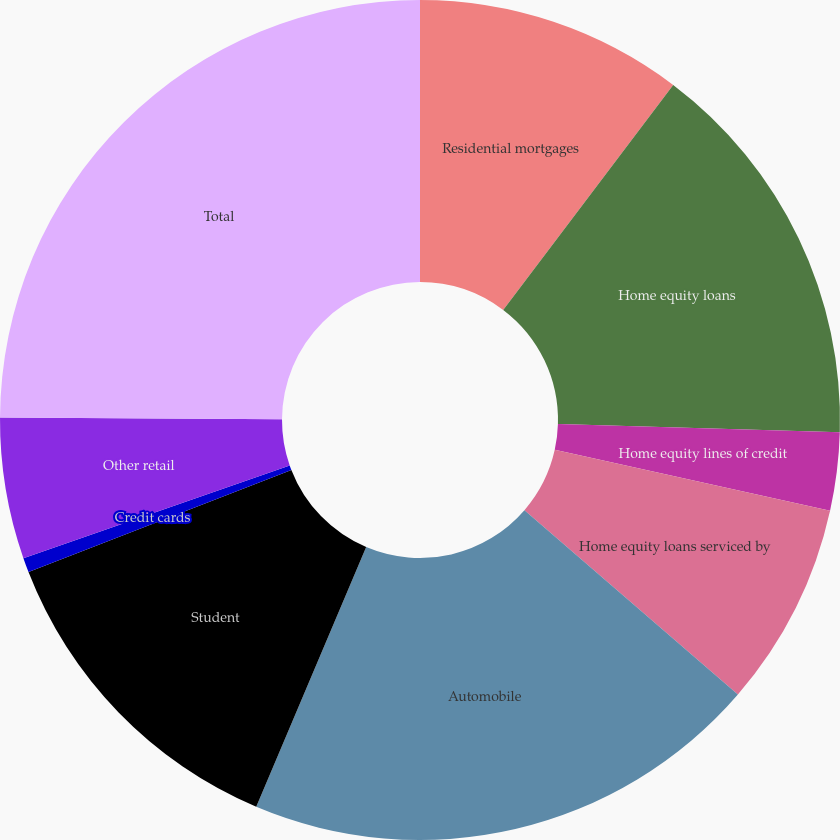Convert chart. <chart><loc_0><loc_0><loc_500><loc_500><pie_chart><fcel>Residential mortgages<fcel>Home equity loans<fcel>Home equity lines of credit<fcel>Home equity loans serviced by<fcel>Automobile<fcel>Student<fcel>Credit cards<fcel>Other retail<fcel>Total<nl><fcel>10.3%<fcel>15.17%<fcel>3.0%<fcel>7.87%<fcel>20.04%<fcel>12.73%<fcel>0.56%<fcel>5.43%<fcel>24.91%<nl></chart> 